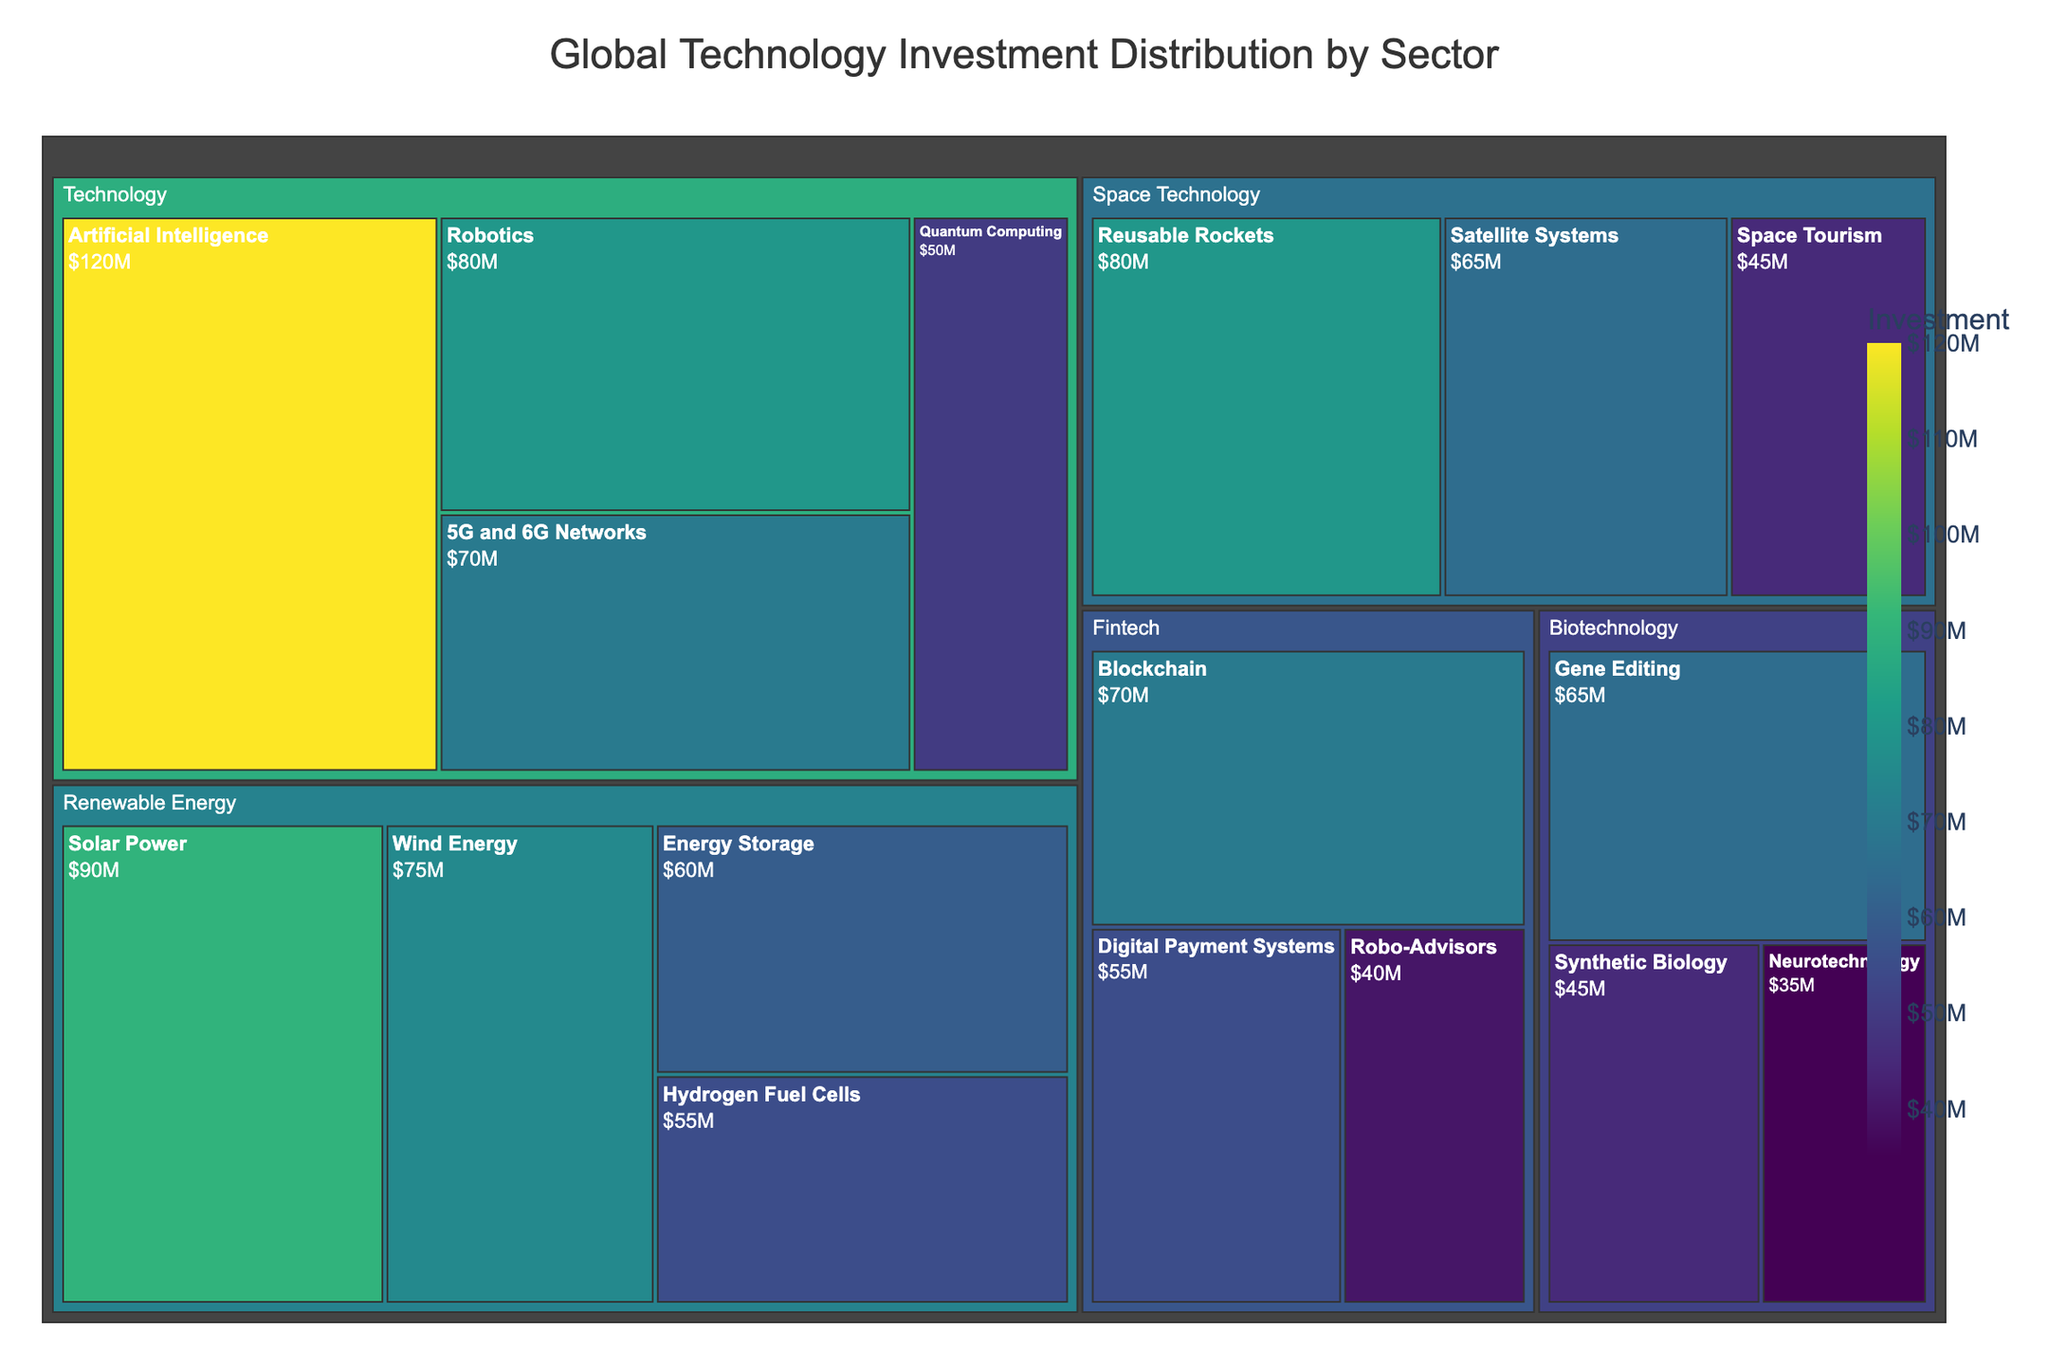What's the title of the figure? The title is usually positioned at the top of the figure and is used to describe what the visualization is about. In this case, it informs us that the treemap represents "Global Technology Investment Distribution by Sector".
Answer: Global Technology Investment Distribution by Sector Which subsector within the Technology sector has the highest investment? To find the subsector with the highest investment within the Technology sector, locate the Technology section in the treemap, and identify which subsector has the largest area or the highest value shown.
Answer: Artificial Intelligence What is the total investment in the Biotechnology sector? Sum the investments for all subsectors within the Biotechnology sector. These subsectors are Gene Editing ($65M), Synthetic Biology ($45M), and Neurotechnology ($35M). Adding these gives 65 + 45 + 35.
Answer: $145M How does the investment in 5G and 6G Networks compare to Energy Storage? Find the investment values for both subsectors: 5G and 6G Networks in Technology ($70M) and Energy Storage in Renewable Energy ($60M). Compare these two values to determine which is greater.
Answer: 5G and 6G Networks have $10M more investment than Energy Storage Which sector has the most diverse investment distribution among its subsectors? To determine the sector with the most diverse investment distribution, look for the sector with subsectors that have investments varying greatly in size. Compare the range and distribution of investments across sectors like Technology, Biotechnology, Renewable Energy, Fintech, and Space Technology. Space Technology has values ranging from $45M to $80M.
Answer: Space Technology What is the combined investment in Renewable Energy's Solar Power and Wind Energy subsectors? Locate the Solar Power ($90M) and Wind Energy ($75M) subsectors in the Renewable Energy sector. Add these figures together: 90 + 75.
Answer: $165M Are there any sectors where all subsectors have an investment below $70M? Examine each sector and check the investment values of their respective subsectors. Sum the investments of Fintech: Blockchain ($70M), Digital Payment Systems ($55M), and Robo-Advisors ($40M). Note the individual values and compare.
Answer: No, Fintech has one subsector (Blockchain) at exactly $70M Which subsector has the lowest investment within the Space Technology sector? Identify the Space Technology sector and compare the investments of its subsectors: Satellite Systems ($65M), Reusable Rockets ($80M), and Space Tourism ($45M). The smallest of these values is the answer.
Answer: Space Tourism What is the percentage of total investment in Artificial Intelligence compared to the entire Technology sector? First, find the total investment in the Technology sector by summing all its subsectors: AI ($120M), Robotics ($80M), Quantum Computing ($50M), and 5G and 6G Networks ($70M). Total = 120 + 80 + 50 + 70 = $320M. Then, calculate the percentage for AI: (120/320) * 100%.
Answer: 37.5% 